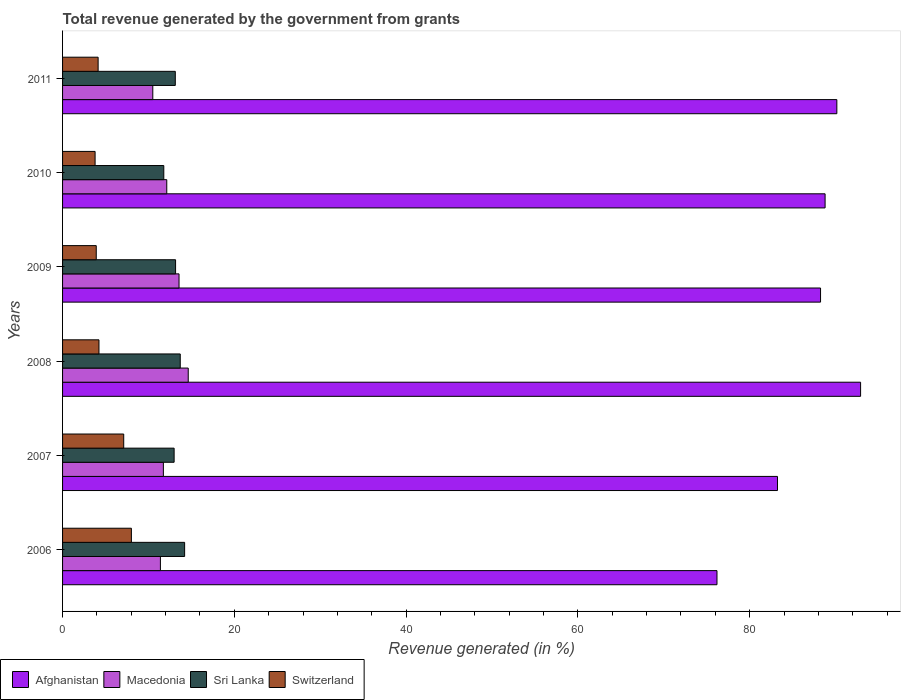How many different coloured bars are there?
Your answer should be very brief. 4. What is the label of the 4th group of bars from the top?
Give a very brief answer. 2008. In how many cases, is the number of bars for a given year not equal to the number of legend labels?
Make the answer very short. 0. What is the total revenue generated in Sri Lanka in 2011?
Ensure brevity in your answer.  13.13. Across all years, what is the maximum total revenue generated in Switzerland?
Provide a short and direct response. 8.01. Across all years, what is the minimum total revenue generated in Macedonia?
Ensure brevity in your answer.  10.51. What is the total total revenue generated in Afghanistan in the graph?
Provide a short and direct response. 519.54. What is the difference between the total revenue generated in Switzerland in 2006 and that in 2010?
Your response must be concise. 4.23. What is the difference between the total revenue generated in Macedonia in 2009 and the total revenue generated in Switzerland in 2011?
Ensure brevity in your answer.  9.42. What is the average total revenue generated in Switzerland per year?
Give a very brief answer. 5.2. In the year 2007, what is the difference between the total revenue generated in Macedonia and total revenue generated in Switzerland?
Give a very brief answer. 4.62. In how many years, is the total revenue generated in Afghanistan greater than 80 %?
Ensure brevity in your answer.  5. What is the ratio of the total revenue generated in Afghanistan in 2006 to that in 2010?
Your response must be concise. 0.86. Is the total revenue generated in Sri Lanka in 2006 less than that in 2010?
Your response must be concise. No. What is the difference between the highest and the second highest total revenue generated in Sri Lanka?
Your answer should be very brief. 0.51. What is the difference between the highest and the lowest total revenue generated in Macedonia?
Provide a short and direct response. 4.12. In how many years, is the total revenue generated in Macedonia greater than the average total revenue generated in Macedonia taken over all years?
Ensure brevity in your answer.  2. Is it the case that in every year, the sum of the total revenue generated in Macedonia and total revenue generated in Switzerland is greater than the sum of total revenue generated in Sri Lanka and total revenue generated in Afghanistan?
Give a very brief answer. Yes. What does the 4th bar from the top in 2007 represents?
Offer a terse response. Afghanistan. What does the 3rd bar from the bottom in 2010 represents?
Provide a succinct answer. Sri Lanka. How many bars are there?
Your answer should be very brief. 24. How many years are there in the graph?
Your answer should be compact. 6. Are the values on the major ticks of X-axis written in scientific E-notation?
Your answer should be very brief. No. Where does the legend appear in the graph?
Ensure brevity in your answer.  Bottom left. How are the legend labels stacked?
Your answer should be compact. Horizontal. What is the title of the graph?
Give a very brief answer. Total revenue generated by the government from grants. What is the label or title of the X-axis?
Offer a terse response. Revenue generated (in %). What is the Revenue generated (in %) of Afghanistan in 2006?
Give a very brief answer. 76.2. What is the Revenue generated (in %) in Macedonia in 2006?
Your response must be concise. 11.39. What is the Revenue generated (in %) of Sri Lanka in 2006?
Provide a succinct answer. 14.21. What is the Revenue generated (in %) of Switzerland in 2006?
Your answer should be compact. 8.01. What is the Revenue generated (in %) in Afghanistan in 2007?
Provide a short and direct response. 83.24. What is the Revenue generated (in %) in Macedonia in 2007?
Your response must be concise. 11.74. What is the Revenue generated (in %) of Sri Lanka in 2007?
Offer a terse response. 12.99. What is the Revenue generated (in %) in Switzerland in 2007?
Make the answer very short. 7.12. What is the Revenue generated (in %) of Afghanistan in 2008?
Make the answer very short. 92.92. What is the Revenue generated (in %) of Macedonia in 2008?
Your response must be concise. 14.63. What is the Revenue generated (in %) of Sri Lanka in 2008?
Provide a succinct answer. 13.7. What is the Revenue generated (in %) of Switzerland in 2008?
Your answer should be very brief. 4.24. What is the Revenue generated (in %) in Afghanistan in 2009?
Give a very brief answer. 88.25. What is the Revenue generated (in %) in Macedonia in 2009?
Your answer should be compact. 13.56. What is the Revenue generated (in %) of Sri Lanka in 2009?
Provide a succinct answer. 13.16. What is the Revenue generated (in %) in Switzerland in 2009?
Provide a succinct answer. 3.92. What is the Revenue generated (in %) in Afghanistan in 2010?
Offer a terse response. 88.78. What is the Revenue generated (in %) in Macedonia in 2010?
Give a very brief answer. 12.13. What is the Revenue generated (in %) in Sri Lanka in 2010?
Provide a short and direct response. 11.79. What is the Revenue generated (in %) of Switzerland in 2010?
Provide a succinct answer. 3.79. What is the Revenue generated (in %) of Afghanistan in 2011?
Offer a terse response. 90.15. What is the Revenue generated (in %) in Macedonia in 2011?
Provide a short and direct response. 10.51. What is the Revenue generated (in %) of Sri Lanka in 2011?
Your answer should be very brief. 13.13. What is the Revenue generated (in %) of Switzerland in 2011?
Your answer should be compact. 4.14. Across all years, what is the maximum Revenue generated (in %) of Afghanistan?
Your answer should be compact. 92.92. Across all years, what is the maximum Revenue generated (in %) of Macedonia?
Make the answer very short. 14.63. Across all years, what is the maximum Revenue generated (in %) in Sri Lanka?
Provide a succinct answer. 14.21. Across all years, what is the maximum Revenue generated (in %) in Switzerland?
Your answer should be very brief. 8.01. Across all years, what is the minimum Revenue generated (in %) in Afghanistan?
Give a very brief answer. 76.2. Across all years, what is the minimum Revenue generated (in %) of Macedonia?
Make the answer very short. 10.51. Across all years, what is the minimum Revenue generated (in %) of Sri Lanka?
Offer a terse response. 11.79. Across all years, what is the minimum Revenue generated (in %) of Switzerland?
Provide a short and direct response. 3.79. What is the total Revenue generated (in %) of Afghanistan in the graph?
Ensure brevity in your answer.  519.54. What is the total Revenue generated (in %) of Macedonia in the graph?
Give a very brief answer. 73.96. What is the total Revenue generated (in %) in Sri Lanka in the graph?
Offer a terse response. 78.97. What is the total Revenue generated (in %) in Switzerland in the graph?
Keep it short and to the point. 31.22. What is the difference between the Revenue generated (in %) in Afghanistan in 2006 and that in 2007?
Offer a very short reply. -7.04. What is the difference between the Revenue generated (in %) of Macedonia in 2006 and that in 2007?
Your answer should be very brief. -0.35. What is the difference between the Revenue generated (in %) of Sri Lanka in 2006 and that in 2007?
Keep it short and to the point. 1.22. What is the difference between the Revenue generated (in %) in Switzerland in 2006 and that in 2007?
Give a very brief answer. 0.89. What is the difference between the Revenue generated (in %) in Afghanistan in 2006 and that in 2008?
Give a very brief answer. -16.72. What is the difference between the Revenue generated (in %) of Macedonia in 2006 and that in 2008?
Offer a very short reply. -3.24. What is the difference between the Revenue generated (in %) of Sri Lanka in 2006 and that in 2008?
Provide a succinct answer. 0.51. What is the difference between the Revenue generated (in %) of Switzerland in 2006 and that in 2008?
Give a very brief answer. 3.77. What is the difference between the Revenue generated (in %) of Afghanistan in 2006 and that in 2009?
Make the answer very short. -12.06. What is the difference between the Revenue generated (in %) of Macedonia in 2006 and that in 2009?
Offer a terse response. -2.17. What is the difference between the Revenue generated (in %) in Sri Lanka in 2006 and that in 2009?
Make the answer very short. 1.05. What is the difference between the Revenue generated (in %) in Switzerland in 2006 and that in 2009?
Ensure brevity in your answer.  4.09. What is the difference between the Revenue generated (in %) of Afghanistan in 2006 and that in 2010?
Offer a very short reply. -12.59. What is the difference between the Revenue generated (in %) of Macedonia in 2006 and that in 2010?
Make the answer very short. -0.74. What is the difference between the Revenue generated (in %) of Sri Lanka in 2006 and that in 2010?
Your response must be concise. 2.43. What is the difference between the Revenue generated (in %) in Switzerland in 2006 and that in 2010?
Offer a terse response. 4.23. What is the difference between the Revenue generated (in %) of Afghanistan in 2006 and that in 2011?
Your response must be concise. -13.96. What is the difference between the Revenue generated (in %) of Macedonia in 2006 and that in 2011?
Your answer should be very brief. 0.89. What is the difference between the Revenue generated (in %) of Sri Lanka in 2006 and that in 2011?
Your response must be concise. 1.09. What is the difference between the Revenue generated (in %) of Switzerland in 2006 and that in 2011?
Offer a very short reply. 3.87. What is the difference between the Revenue generated (in %) of Afghanistan in 2007 and that in 2008?
Your answer should be compact. -9.68. What is the difference between the Revenue generated (in %) in Macedonia in 2007 and that in 2008?
Offer a terse response. -2.89. What is the difference between the Revenue generated (in %) of Sri Lanka in 2007 and that in 2008?
Make the answer very short. -0.71. What is the difference between the Revenue generated (in %) in Switzerland in 2007 and that in 2008?
Keep it short and to the point. 2.88. What is the difference between the Revenue generated (in %) of Afghanistan in 2007 and that in 2009?
Offer a very short reply. -5.01. What is the difference between the Revenue generated (in %) in Macedonia in 2007 and that in 2009?
Ensure brevity in your answer.  -1.82. What is the difference between the Revenue generated (in %) of Sri Lanka in 2007 and that in 2009?
Make the answer very short. -0.17. What is the difference between the Revenue generated (in %) of Switzerland in 2007 and that in 2009?
Keep it short and to the point. 3.2. What is the difference between the Revenue generated (in %) of Afghanistan in 2007 and that in 2010?
Provide a succinct answer. -5.54. What is the difference between the Revenue generated (in %) in Macedonia in 2007 and that in 2010?
Keep it short and to the point. -0.39. What is the difference between the Revenue generated (in %) of Sri Lanka in 2007 and that in 2010?
Your answer should be compact. 1.2. What is the difference between the Revenue generated (in %) of Switzerland in 2007 and that in 2010?
Keep it short and to the point. 3.33. What is the difference between the Revenue generated (in %) in Afghanistan in 2007 and that in 2011?
Provide a succinct answer. -6.91. What is the difference between the Revenue generated (in %) of Macedonia in 2007 and that in 2011?
Offer a terse response. 1.23. What is the difference between the Revenue generated (in %) in Sri Lanka in 2007 and that in 2011?
Ensure brevity in your answer.  -0.14. What is the difference between the Revenue generated (in %) of Switzerland in 2007 and that in 2011?
Keep it short and to the point. 2.98. What is the difference between the Revenue generated (in %) of Afghanistan in 2008 and that in 2009?
Ensure brevity in your answer.  4.66. What is the difference between the Revenue generated (in %) in Macedonia in 2008 and that in 2009?
Your response must be concise. 1.07. What is the difference between the Revenue generated (in %) of Sri Lanka in 2008 and that in 2009?
Provide a succinct answer. 0.55. What is the difference between the Revenue generated (in %) in Switzerland in 2008 and that in 2009?
Give a very brief answer. 0.32. What is the difference between the Revenue generated (in %) of Afghanistan in 2008 and that in 2010?
Offer a very short reply. 4.13. What is the difference between the Revenue generated (in %) in Macedonia in 2008 and that in 2010?
Your answer should be very brief. 2.5. What is the difference between the Revenue generated (in %) in Sri Lanka in 2008 and that in 2010?
Your answer should be compact. 1.92. What is the difference between the Revenue generated (in %) of Switzerland in 2008 and that in 2010?
Your answer should be very brief. 0.45. What is the difference between the Revenue generated (in %) of Afghanistan in 2008 and that in 2011?
Offer a terse response. 2.76. What is the difference between the Revenue generated (in %) in Macedonia in 2008 and that in 2011?
Provide a succinct answer. 4.12. What is the difference between the Revenue generated (in %) in Sri Lanka in 2008 and that in 2011?
Offer a terse response. 0.58. What is the difference between the Revenue generated (in %) of Switzerland in 2008 and that in 2011?
Offer a terse response. 0.1. What is the difference between the Revenue generated (in %) of Afghanistan in 2009 and that in 2010?
Offer a very short reply. -0.53. What is the difference between the Revenue generated (in %) in Macedonia in 2009 and that in 2010?
Ensure brevity in your answer.  1.43. What is the difference between the Revenue generated (in %) in Sri Lanka in 2009 and that in 2010?
Provide a short and direct response. 1.37. What is the difference between the Revenue generated (in %) in Switzerland in 2009 and that in 2010?
Offer a very short reply. 0.13. What is the difference between the Revenue generated (in %) of Afghanistan in 2009 and that in 2011?
Your response must be concise. -1.9. What is the difference between the Revenue generated (in %) of Macedonia in 2009 and that in 2011?
Your answer should be very brief. 3.05. What is the difference between the Revenue generated (in %) of Sri Lanka in 2009 and that in 2011?
Keep it short and to the point. 0.03. What is the difference between the Revenue generated (in %) in Switzerland in 2009 and that in 2011?
Your response must be concise. -0.22. What is the difference between the Revenue generated (in %) in Afghanistan in 2010 and that in 2011?
Give a very brief answer. -1.37. What is the difference between the Revenue generated (in %) of Macedonia in 2010 and that in 2011?
Provide a succinct answer. 1.63. What is the difference between the Revenue generated (in %) of Sri Lanka in 2010 and that in 2011?
Offer a terse response. -1.34. What is the difference between the Revenue generated (in %) of Switzerland in 2010 and that in 2011?
Make the answer very short. -0.35. What is the difference between the Revenue generated (in %) of Afghanistan in 2006 and the Revenue generated (in %) of Macedonia in 2007?
Provide a succinct answer. 64.46. What is the difference between the Revenue generated (in %) in Afghanistan in 2006 and the Revenue generated (in %) in Sri Lanka in 2007?
Your answer should be compact. 63.21. What is the difference between the Revenue generated (in %) in Afghanistan in 2006 and the Revenue generated (in %) in Switzerland in 2007?
Make the answer very short. 69.08. What is the difference between the Revenue generated (in %) of Macedonia in 2006 and the Revenue generated (in %) of Sri Lanka in 2007?
Provide a short and direct response. -1.6. What is the difference between the Revenue generated (in %) in Macedonia in 2006 and the Revenue generated (in %) in Switzerland in 2007?
Make the answer very short. 4.27. What is the difference between the Revenue generated (in %) of Sri Lanka in 2006 and the Revenue generated (in %) of Switzerland in 2007?
Give a very brief answer. 7.09. What is the difference between the Revenue generated (in %) of Afghanistan in 2006 and the Revenue generated (in %) of Macedonia in 2008?
Provide a short and direct response. 61.56. What is the difference between the Revenue generated (in %) of Afghanistan in 2006 and the Revenue generated (in %) of Sri Lanka in 2008?
Your response must be concise. 62.49. What is the difference between the Revenue generated (in %) in Afghanistan in 2006 and the Revenue generated (in %) in Switzerland in 2008?
Your answer should be very brief. 71.96. What is the difference between the Revenue generated (in %) of Macedonia in 2006 and the Revenue generated (in %) of Sri Lanka in 2008?
Your answer should be compact. -2.31. What is the difference between the Revenue generated (in %) of Macedonia in 2006 and the Revenue generated (in %) of Switzerland in 2008?
Offer a very short reply. 7.15. What is the difference between the Revenue generated (in %) in Sri Lanka in 2006 and the Revenue generated (in %) in Switzerland in 2008?
Your answer should be compact. 9.97. What is the difference between the Revenue generated (in %) of Afghanistan in 2006 and the Revenue generated (in %) of Macedonia in 2009?
Give a very brief answer. 62.64. What is the difference between the Revenue generated (in %) of Afghanistan in 2006 and the Revenue generated (in %) of Sri Lanka in 2009?
Provide a succinct answer. 63.04. What is the difference between the Revenue generated (in %) of Afghanistan in 2006 and the Revenue generated (in %) of Switzerland in 2009?
Provide a short and direct response. 72.27. What is the difference between the Revenue generated (in %) of Macedonia in 2006 and the Revenue generated (in %) of Sri Lanka in 2009?
Keep it short and to the point. -1.77. What is the difference between the Revenue generated (in %) in Macedonia in 2006 and the Revenue generated (in %) in Switzerland in 2009?
Your response must be concise. 7.47. What is the difference between the Revenue generated (in %) of Sri Lanka in 2006 and the Revenue generated (in %) of Switzerland in 2009?
Give a very brief answer. 10.29. What is the difference between the Revenue generated (in %) in Afghanistan in 2006 and the Revenue generated (in %) in Macedonia in 2010?
Your response must be concise. 64.06. What is the difference between the Revenue generated (in %) of Afghanistan in 2006 and the Revenue generated (in %) of Sri Lanka in 2010?
Give a very brief answer. 64.41. What is the difference between the Revenue generated (in %) of Afghanistan in 2006 and the Revenue generated (in %) of Switzerland in 2010?
Provide a succinct answer. 72.41. What is the difference between the Revenue generated (in %) in Macedonia in 2006 and the Revenue generated (in %) in Sri Lanka in 2010?
Your response must be concise. -0.39. What is the difference between the Revenue generated (in %) of Macedonia in 2006 and the Revenue generated (in %) of Switzerland in 2010?
Make the answer very short. 7.61. What is the difference between the Revenue generated (in %) in Sri Lanka in 2006 and the Revenue generated (in %) in Switzerland in 2010?
Your answer should be compact. 10.43. What is the difference between the Revenue generated (in %) in Afghanistan in 2006 and the Revenue generated (in %) in Macedonia in 2011?
Offer a very short reply. 65.69. What is the difference between the Revenue generated (in %) of Afghanistan in 2006 and the Revenue generated (in %) of Sri Lanka in 2011?
Your answer should be compact. 63.07. What is the difference between the Revenue generated (in %) of Afghanistan in 2006 and the Revenue generated (in %) of Switzerland in 2011?
Your answer should be compact. 72.05. What is the difference between the Revenue generated (in %) in Macedonia in 2006 and the Revenue generated (in %) in Sri Lanka in 2011?
Your response must be concise. -1.73. What is the difference between the Revenue generated (in %) in Macedonia in 2006 and the Revenue generated (in %) in Switzerland in 2011?
Give a very brief answer. 7.25. What is the difference between the Revenue generated (in %) of Sri Lanka in 2006 and the Revenue generated (in %) of Switzerland in 2011?
Keep it short and to the point. 10.07. What is the difference between the Revenue generated (in %) of Afghanistan in 2007 and the Revenue generated (in %) of Macedonia in 2008?
Offer a terse response. 68.61. What is the difference between the Revenue generated (in %) of Afghanistan in 2007 and the Revenue generated (in %) of Sri Lanka in 2008?
Give a very brief answer. 69.54. What is the difference between the Revenue generated (in %) of Afghanistan in 2007 and the Revenue generated (in %) of Switzerland in 2008?
Keep it short and to the point. 79. What is the difference between the Revenue generated (in %) of Macedonia in 2007 and the Revenue generated (in %) of Sri Lanka in 2008?
Your answer should be compact. -1.97. What is the difference between the Revenue generated (in %) in Macedonia in 2007 and the Revenue generated (in %) in Switzerland in 2008?
Your answer should be very brief. 7.5. What is the difference between the Revenue generated (in %) in Sri Lanka in 2007 and the Revenue generated (in %) in Switzerland in 2008?
Ensure brevity in your answer.  8.75. What is the difference between the Revenue generated (in %) of Afghanistan in 2007 and the Revenue generated (in %) of Macedonia in 2009?
Your answer should be compact. 69.68. What is the difference between the Revenue generated (in %) in Afghanistan in 2007 and the Revenue generated (in %) in Sri Lanka in 2009?
Your response must be concise. 70.08. What is the difference between the Revenue generated (in %) of Afghanistan in 2007 and the Revenue generated (in %) of Switzerland in 2009?
Keep it short and to the point. 79.32. What is the difference between the Revenue generated (in %) in Macedonia in 2007 and the Revenue generated (in %) in Sri Lanka in 2009?
Provide a succinct answer. -1.42. What is the difference between the Revenue generated (in %) of Macedonia in 2007 and the Revenue generated (in %) of Switzerland in 2009?
Make the answer very short. 7.82. What is the difference between the Revenue generated (in %) in Sri Lanka in 2007 and the Revenue generated (in %) in Switzerland in 2009?
Keep it short and to the point. 9.07. What is the difference between the Revenue generated (in %) of Afghanistan in 2007 and the Revenue generated (in %) of Macedonia in 2010?
Your answer should be very brief. 71.11. What is the difference between the Revenue generated (in %) in Afghanistan in 2007 and the Revenue generated (in %) in Sri Lanka in 2010?
Your answer should be very brief. 71.45. What is the difference between the Revenue generated (in %) in Afghanistan in 2007 and the Revenue generated (in %) in Switzerland in 2010?
Offer a very short reply. 79.45. What is the difference between the Revenue generated (in %) of Macedonia in 2007 and the Revenue generated (in %) of Sri Lanka in 2010?
Your answer should be very brief. -0.05. What is the difference between the Revenue generated (in %) of Macedonia in 2007 and the Revenue generated (in %) of Switzerland in 2010?
Offer a very short reply. 7.95. What is the difference between the Revenue generated (in %) of Sri Lanka in 2007 and the Revenue generated (in %) of Switzerland in 2010?
Offer a terse response. 9.2. What is the difference between the Revenue generated (in %) of Afghanistan in 2007 and the Revenue generated (in %) of Macedonia in 2011?
Your response must be concise. 72.73. What is the difference between the Revenue generated (in %) in Afghanistan in 2007 and the Revenue generated (in %) in Sri Lanka in 2011?
Make the answer very short. 70.11. What is the difference between the Revenue generated (in %) in Afghanistan in 2007 and the Revenue generated (in %) in Switzerland in 2011?
Offer a terse response. 79.1. What is the difference between the Revenue generated (in %) in Macedonia in 2007 and the Revenue generated (in %) in Sri Lanka in 2011?
Provide a short and direct response. -1.39. What is the difference between the Revenue generated (in %) of Macedonia in 2007 and the Revenue generated (in %) of Switzerland in 2011?
Ensure brevity in your answer.  7.6. What is the difference between the Revenue generated (in %) in Sri Lanka in 2007 and the Revenue generated (in %) in Switzerland in 2011?
Keep it short and to the point. 8.85. What is the difference between the Revenue generated (in %) of Afghanistan in 2008 and the Revenue generated (in %) of Macedonia in 2009?
Provide a short and direct response. 79.36. What is the difference between the Revenue generated (in %) of Afghanistan in 2008 and the Revenue generated (in %) of Sri Lanka in 2009?
Offer a very short reply. 79.76. What is the difference between the Revenue generated (in %) of Afghanistan in 2008 and the Revenue generated (in %) of Switzerland in 2009?
Your answer should be compact. 88.99. What is the difference between the Revenue generated (in %) of Macedonia in 2008 and the Revenue generated (in %) of Sri Lanka in 2009?
Provide a short and direct response. 1.47. What is the difference between the Revenue generated (in %) of Macedonia in 2008 and the Revenue generated (in %) of Switzerland in 2009?
Make the answer very short. 10.71. What is the difference between the Revenue generated (in %) in Sri Lanka in 2008 and the Revenue generated (in %) in Switzerland in 2009?
Offer a very short reply. 9.78. What is the difference between the Revenue generated (in %) in Afghanistan in 2008 and the Revenue generated (in %) in Macedonia in 2010?
Give a very brief answer. 80.78. What is the difference between the Revenue generated (in %) in Afghanistan in 2008 and the Revenue generated (in %) in Sri Lanka in 2010?
Give a very brief answer. 81.13. What is the difference between the Revenue generated (in %) of Afghanistan in 2008 and the Revenue generated (in %) of Switzerland in 2010?
Make the answer very short. 89.13. What is the difference between the Revenue generated (in %) of Macedonia in 2008 and the Revenue generated (in %) of Sri Lanka in 2010?
Offer a terse response. 2.84. What is the difference between the Revenue generated (in %) of Macedonia in 2008 and the Revenue generated (in %) of Switzerland in 2010?
Your response must be concise. 10.84. What is the difference between the Revenue generated (in %) of Sri Lanka in 2008 and the Revenue generated (in %) of Switzerland in 2010?
Your response must be concise. 9.92. What is the difference between the Revenue generated (in %) in Afghanistan in 2008 and the Revenue generated (in %) in Macedonia in 2011?
Make the answer very short. 82.41. What is the difference between the Revenue generated (in %) of Afghanistan in 2008 and the Revenue generated (in %) of Sri Lanka in 2011?
Keep it short and to the point. 79.79. What is the difference between the Revenue generated (in %) in Afghanistan in 2008 and the Revenue generated (in %) in Switzerland in 2011?
Give a very brief answer. 88.78. What is the difference between the Revenue generated (in %) in Macedonia in 2008 and the Revenue generated (in %) in Sri Lanka in 2011?
Your response must be concise. 1.51. What is the difference between the Revenue generated (in %) of Macedonia in 2008 and the Revenue generated (in %) of Switzerland in 2011?
Ensure brevity in your answer.  10.49. What is the difference between the Revenue generated (in %) in Sri Lanka in 2008 and the Revenue generated (in %) in Switzerland in 2011?
Give a very brief answer. 9.56. What is the difference between the Revenue generated (in %) in Afghanistan in 2009 and the Revenue generated (in %) in Macedonia in 2010?
Give a very brief answer. 76.12. What is the difference between the Revenue generated (in %) in Afghanistan in 2009 and the Revenue generated (in %) in Sri Lanka in 2010?
Keep it short and to the point. 76.47. What is the difference between the Revenue generated (in %) in Afghanistan in 2009 and the Revenue generated (in %) in Switzerland in 2010?
Keep it short and to the point. 84.47. What is the difference between the Revenue generated (in %) in Macedonia in 2009 and the Revenue generated (in %) in Sri Lanka in 2010?
Your answer should be compact. 1.77. What is the difference between the Revenue generated (in %) of Macedonia in 2009 and the Revenue generated (in %) of Switzerland in 2010?
Provide a succinct answer. 9.77. What is the difference between the Revenue generated (in %) of Sri Lanka in 2009 and the Revenue generated (in %) of Switzerland in 2010?
Give a very brief answer. 9.37. What is the difference between the Revenue generated (in %) of Afghanistan in 2009 and the Revenue generated (in %) of Macedonia in 2011?
Offer a terse response. 77.75. What is the difference between the Revenue generated (in %) in Afghanistan in 2009 and the Revenue generated (in %) in Sri Lanka in 2011?
Your answer should be compact. 75.13. What is the difference between the Revenue generated (in %) of Afghanistan in 2009 and the Revenue generated (in %) of Switzerland in 2011?
Ensure brevity in your answer.  84.11. What is the difference between the Revenue generated (in %) of Macedonia in 2009 and the Revenue generated (in %) of Sri Lanka in 2011?
Provide a short and direct response. 0.43. What is the difference between the Revenue generated (in %) of Macedonia in 2009 and the Revenue generated (in %) of Switzerland in 2011?
Provide a short and direct response. 9.42. What is the difference between the Revenue generated (in %) of Sri Lanka in 2009 and the Revenue generated (in %) of Switzerland in 2011?
Ensure brevity in your answer.  9.02. What is the difference between the Revenue generated (in %) in Afghanistan in 2010 and the Revenue generated (in %) in Macedonia in 2011?
Offer a terse response. 78.28. What is the difference between the Revenue generated (in %) in Afghanistan in 2010 and the Revenue generated (in %) in Sri Lanka in 2011?
Ensure brevity in your answer.  75.66. What is the difference between the Revenue generated (in %) of Afghanistan in 2010 and the Revenue generated (in %) of Switzerland in 2011?
Your answer should be very brief. 84.64. What is the difference between the Revenue generated (in %) of Macedonia in 2010 and the Revenue generated (in %) of Sri Lanka in 2011?
Give a very brief answer. -0.99. What is the difference between the Revenue generated (in %) of Macedonia in 2010 and the Revenue generated (in %) of Switzerland in 2011?
Your response must be concise. 7.99. What is the difference between the Revenue generated (in %) in Sri Lanka in 2010 and the Revenue generated (in %) in Switzerland in 2011?
Make the answer very short. 7.65. What is the average Revenue generated (in %) of Afghanistan per year?
Make the answer very short. 86.59. What is the average Revenue generated (in %) of Macedonia per year?
Keep it short and to the point. 12.33. What is the average Revenue generated (in %) of Sri Lanka per year?
Your answer should be very brief. 13.16. What is the average Revenue generated (in %) in Switzerland per year?
Ensure brevity in your answer.  5.2. In the year 2006, what is the difference between the Revenue generated (in %) in Afghanistan and Revenue generated (in %) in Macedonia?
Give a very brief answer. 64.8. In the year 2006, what is the difference between the Revenue generated (in %) in Afghanistan and Revenue generated (in %) in Sri Lanka?
Make the answer very short. 61.98. In the year 2006, what is the difference between the Revenue generated (in %) in Afghanistan and Revenue generated (in %) in Switzerland?
Offer a terse response. 68.18. In the year 2006, what is the difference between the Revenue generated (in %) in Macedonia and Revenue generated (in %) in Sri Lanka?
Offer a very short reply. -2.82. In the year 2006, what is the difference between the Revenue generated (in %) in Macedonia and Revenue generated (in %) in Switzerland?
Your response must be concise. 3.38. In the year 2006, what is the difference between the Revenue generated (in %) of Sri Lanka and Revenue generated (in %) of Switzerland?
Keep it short and to the point. 6.2. In the year 2007, what is the difference between the Revenue generated (in %) in Afghanistan and Revenue generated (in %) in Macedonia?
Your answer should be compact. 71.5. In the year 2007, what is the difference between the Revenue generated (in %) in Afghanistan and Revenue generated (in %) in Sri Lanka?
Offer a very short reply. 70.25. In the year 2007, what is the difference between the Revenue generated (in %) of Afghanistan and Revenue generated (in %) of Switzerland?
Keep it short and to the point. 76.12. In the year 2007, what is the difference between the Revenue generated (in %) in Macedonia and Revenue generated (in %) in Sri Lanka?
Offer a terse response. -1.25. In the year 2007, what is the difference between the Revenue generated (in %) in Macedonia and Revenue generated (in %) in Switzerland?
Keep it short and to the point. 4.62. In the year 2007, what is the difference between the Revenue generated (in %) in Sri Lanka and Revenue generated (in %) in Switzerland?
Offer a terse response. 5.87. In the year 2008, what is the difference between the Revenue generated (in %) in Afghanistan and Revenue generated (in %) in Macedonia?
Give a very brief answer. 78.29. In the year 2008, what is the difference between the Revenue generated (in %) of Afghanistan and Revenue generated (in %) of Sri Lanka?
Provide a succinct answer. 79.21. In the year 2008, what is the difference between the Revenue generated (in %) of Afghanistan and Revenue generated (in %) of Switzerland?
Your answer should be very brief. 88.68. In the year 2008, what is the difference between the Revenue generated (in %) in Macedonia and Revenue generated (in %) in Sri Lanka?
Provide a succinct answer. 0.93. In the year 2008, what is the difference between the Revenue generated (in %) of Macedonia and Revenue generated (in %) of Switzerland?
Provide a succinct answer. 10.39. In the year 2008, what is the difference between the Revenue generated (in %) in Sri Lanka and Revenue generated (in %) in Switzerland?
Offer a terse response. 9.46. In the year 2009, what is the difference between the Revenue generated (in %) in Afghanistan and Revenue generated (in %) in Macedonia?
Offer a terse response. 74.69. In the year 2009, what is the difference between the Revenue generated (in %) in Afghanistan and Revenue generated (in %) in Sri Lanka?
Make the answer very short. 75.1. In the year 2009, what is the difference between the Revenue generated (in %) in Afghanistan and Revenue generated (in %) in Switzerland?
Keep it short and to the point. 84.33. In the year 2009, what is the difference between the Revenue generated (in %) of Macedonia and Revenue generated (in %) of Sri Lanka?
Provide a short and direct response. 0.4. In the year 2009, what is the difference between the Revenue generated (in %) of Macedonia and Revenue generated (in %) of Switzerland?
Give a very brief answer. 9.64. In the year 2009, what is the difference between the Revenue generated (in %) in Sri Lanka and Revenue generated (in %) in Switzerland?
Provide a succinct answer. 9.24. In the year 2010, what is the difference between the Revenue generated (in %) of Afghanistan and Revenue generated (in %) of Macedonia?
Your response must be concise. 76.65. In the year 2010, what is the difference between the Revenue generated (in %) in Afghanistan and Revenue generated (in %) in Sri Lanka?
Provide a short and direct response. 77. In the year 2010, what is the difference between the Revenue generated (in %) in Afghanistan and Revenue generated (in %) in Switzerland?
Offer a terse response. 85. In the year 2010, what is the difference between the Revenue generated (in %) of Macedonia and Revenue generated (in %) of Sri Lanka?
Offer a very short reply. 0.34. In the year 2010, what is the difference between the Revenue generated (in %) of Macedonia and Revenue generated (in %) of Switzerland?
Make the answer very short. 8.34. In the year 2010, what is the difference between the Revenue generated (in %) in Sri Lanka and Revenue generated (in %) in Switzerland?
Offer a terse response. 8. In the year 2011, what is the difference between the Revenue generated (in %) of Afghanistan and Revenue generated (in %) of Macedonia?
Make the answer very short. 79.65. In the year 2011, what is the difference between the Revenue generated (in %) in Afghanistan and Revenue generated (in %) in Sri Lanka?
Give a very brief answer. 77.03. In the year 2011, what is the difference between the Revenue generated (in %) of Afghanistan and Revenue generated (in %) of Switzerland?
Give a very brief answer. 86.01. In the year 2011, what is the difference between the Revenue generated (in %) of Macedonia and Revenue generated (in %) of Sri Lanka?
Make the answer very short. -2.62. In the year 2011, what is the difference between the Revenue generated (in %) in Macedonia and Revenue generated (in %) in Switzerland?
Ensure brevity in your answer.  6.37. In the year 2011, what is the difference between the Revenue generated (in %) of Sri Lanka and Revenue generated (in %) of Switzerland?
Your response must be concise. 8.98. What is the ratio of the Revenue generated (in %) in Afghanistan in 2006 to that in 2007?
Keep it short and to the point. 0.92. What is the ratio of the Revenue generated (in %) of Macedonia in 2006 to that in 2007?
Provide a succinct answer. 0.97. What is the ratio of the Revenue generated (in %) of Sri Lanka in 2006 to that in 2007?
Your answer should be very brief. 1.09. What is the ratio of the Revenue generated (in %) in Switzerland in 2006 to that in 2007?
Your response must be concise. 1.13. What is the ratio of the Revenue generated (in %) of Afghanistan in 2006 to that in 2008?
Offer a very short reply. 0.82. What is the ratio of the Revenue generated (in %) of Macedonia in 2006 to that in 2008?
Offer a very short reply. 0.78. What is the ratio of the Revenue generated (in %) of Sri Lanka in 2006 to that in 2008?
Keep it short and to the point. 1.04. What is the ratio of the Revenue generated (in %) of Switzerland in 2006 to that in 2008?
Make the answer very short. 1.89. What is the ratio of the Revenue generated (in %) in Afghanistan in 2006 to that in 2009?
Offer a terse response. 0.86. What is the ratio of the Revenue generated (in %) of Macedonia in 2006 to that in 2009?
Make the answer very short. 0.84. What is the ratio of the Revenue generated (in %) in Sri Lanka in 2006 to that in 2009?
Keep it short and to the point. 1.08. What is the ratio of the Revenue generated (in %) of Switzerland in 2006 to that in 2009?
Your answer should be compact. 2.04. What is the ratio of the Revenue generated (in %) of Afghanistan in 2006 to that in 2010?
Your response must be concise. 0.86. What is the ratio of the Revenue generated (in %) of Macedonia in 2006 to that in 2010?
Your answer should be compact. 0.94. What is the ratio of the Revenue generated (in %) in Sri Lanka in 2006 to that in 2010?
Ensure brevity in your answer.  1.21. What is the ratio of the Revenue generated (in %) of Switzerland in 2006 to that in 2010?
Provide a short and direct response. 2.12. What is the ratio of the Revenue generated (in %) of Afghanistan in 2006 to that in 2011?
Make the answer very short. 0.85. What is the ratio of the Revenue generated (in %) of Macedonia in 2006 to that in 2011?
Keep it short and to the point. 1.08. What is the ratio of the Revenue generated (in %) in Sri Lanka in 2006 to that in 2011?
Provide a succinct answer. 1.08. What is the ratio of the Revenue generated (in %) of Switzerland in 2006 to that in 2011?
Give a very brief answer. 1.94. What is the ratio of the Revenue generated (in %) of Afghanistan in 2007 to that in 2008?
Ensure brevity in your answer.  0.9. What is the ratio of the Revenue generated (in %) of Macedonia in 2007 to that in 2008?
Ensure brevity in your answer.  0.8. What is the ratio of the Revenue generated (in %) of Sri Lanka in 2007 to that in 2008?
Your answer should be compact. 0.95. What is the ratio of the Revenue generated (in %) of Switzerland in 2007 to that in 2008?
Your answer should be very brief. 1.68. What is the ratio of the Revenue generated (in %) in Afghanistan in 2007 to that in 2009?
Your response must be concise. 0.94. What is the ratio of the Revenue generated (in %) in Macedonia in 2007 to that in 2009?
Give a very brief answer. 0.87. What is the ratio of the Revenue generated (in %) in Sri Lanka in 2007 to that in 2009?
Provide a short and direct response. 0.99. What is the ratio of the Revenue generated (in %) of Switzerland in 2007 to that in 2009?
Your answer should be compact. 1.82. What is the ratio of the Revenue generated (in %) of Afghanistan in 2007 to that in 2010?
Give a very brief answer. 0.94. What is the ratio of the Revenue generated (in %) of Macedonia in 2007 to that in 2010?
Your answer should be compact. 0.97. What is the ratio of the Revenue generated (in %) in Sri Lanka in 2007 to that in 2010?
Your response must be concise. 1.1. What is the ratio of the Revenue generated (in %) of Switzerland in 2007 to that in 2010?
Ensure brevity in your answer.  1.88. What is the ratio of the Revenue generated (in %) in Afghanistan in 2007 to that in 2011?
Offer a very short reply. 0.92. What is the ratio of the Revenue generated (in %) in Macedonia in 2007 to that in 2011?
Give a very brief answer. 1.12. What is the ratio of the Revenue generated (in %) of Switzerland in 2007 to that in 2011?
Offer a terse response. 1.72. What is the ratio of the Revenue generated (in %) of Afghanistan in 2008 to that in 2009?
Your answer should be compact. 1.05. What is the ratio of the Revenue generated (in %) of Macedonia in 2008 to that in 2009?
Your answer should be compact. 1.08. What is the ratio of the Revenue generated (in %) of Sri Lanka in 2008 to that in 2009?
Your answer should be compact. 1.04. What is the ratio of the Revenue generated (in %) in Switzerland in 2008 to that in 2009?
Provide a short and direct response. 1.08. What is the ratio of the Revenue generated (in %) in Afghanistan in 2008 to that in 2010?
Provide a succinct answer. 1.05. What is the ratio of the Revenue generated (in %) in Macedonia in 2008 to that in 2010?
Ensure brevity in your answer.  1.21. What is the ratio of the Revenue generated (in %) of Sri Lanka in 2008 to that in 2010?
Ensure brevity in your answer.  1.16. What is the ratio of the Revenue generated (in %) of Switzerland in 2008 to that in 2010?
Make the answer very short. 1.12. What is the ratio of the Revenue generated (in %) of Afghanistan in 2008 to that in 2011?
Your answer should be compact. 1.03. What is the ratio of the Revenue generated (in %) of Macedonia in 2008 to that in 2011?
Offer a very short reply. 1.39. What is the ratio of the Revenue generated (in %) of Sri Lanka in 2008 to that in 2011?
Give a very brief answer. 1.04. What is the ratio of the Revenue generated (in %) in Switzerland in 2008 to that in 2011?
Offer a very short reply. 1.02. What is the ratio of the Revenue generated (in %) in Macedonia in 2009 to that in 2010?
Provide a succinct answer. 1.12. What is the ratio of the Revenue generated (in %) of Sri Lanka in 2009 to that in 2010?
Give a very brief answer. 1.12. What is the ratio of the Revenue generated (in %) in Switzerland in 2009 to that in 2010?
Your response must be concise. 1.04. What is the ratio of the Revenue generated (in %) in Afghanistan in 2009 to that in 2011?
Give a very brief answer. 0.98. What is the ratio of the Revenue generated (in %) in Macedonia in 2009 to that in 2011?
Provide a succinct answer. 1.29. What is the ratio of the Revenue generated (in %) in Switzerland in 2009 to that in 2011?
Your answer should be compact. 0.95. What is the ratio of the Revenue generated (in %) in Afghanistan in 2010 to that in 2011?
Provide a short and direct response. 0.98. What is the ratio of the Revenue generated (in %) of Macedonia in 2010 to that in 2011?
Offer a terse response. 1.15. What is the ratio of the Revenue generated (in %) of Sri Lanka in 2010 to that in 2011?
Offer a terse response. 0.9. What is the ratio of the Revenue generated (in %) of Switzerland in 2010 to that in 2011?
Offer a very short reply. 0.91. What is the difference between the highest and the second highest Revenue generated (in %) in Afghanistan?
Give a very brief answer. 2.76. What is the difference between the highest and the second highest Revenue generated (in %) in Macedonia?
Your response must be concise. 1.07. What is the difference between the highest and the second highest Revenue generated (in %) of Sri Lanka?
Give a very brief answer. 0.51. What is the difference between the highest and the second highest Revenue generated (in %) in Switzerland?
Provide a short and direct response. 0.89. What is the difference between the highest and the lowest Revenue generated (in %) of Afghanistan?
Your response must be concise. 16.72. What is the difference between the highest and the lowest Revenue generated (in %) in Macedonia?
Ensure brevity in your answer.  4.12. What is the difference between the highest and the lowest Revenue generated (in %) in Sri Lanka?
Provide a short and direct response. 2.43. What is the difference between the highest and the lowest Revenue generated (in %) of Switzerland?
Give a very brief answer. 4.23. 